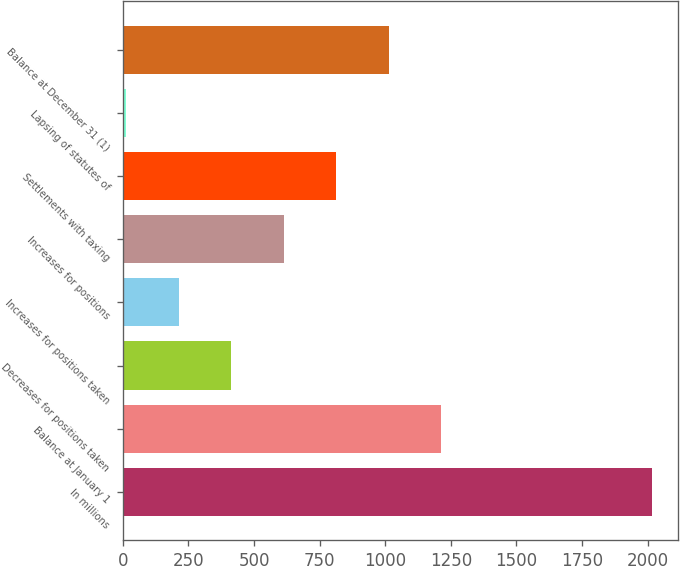Convert chart to OTSL. <chart><loc_0><loc_0><loc_500><loc_500><bar_chart><fcel>In millions<fcel>Balance at January 1<fcel>Decreases for positions taken<fcel>Increases for positions taken<fcel>Increases for positions<fcel>Settlements with taxing<fcel>Lapsing of statutes of<fcel>Balance at December 31 (1)<nl><fcel>2015<fcel>1214.28<fcel>413.56<fcel>213.38<fcel>613.74<fcel>813.92<fcel>13.2<fcel>1014.1<nl></chart> 